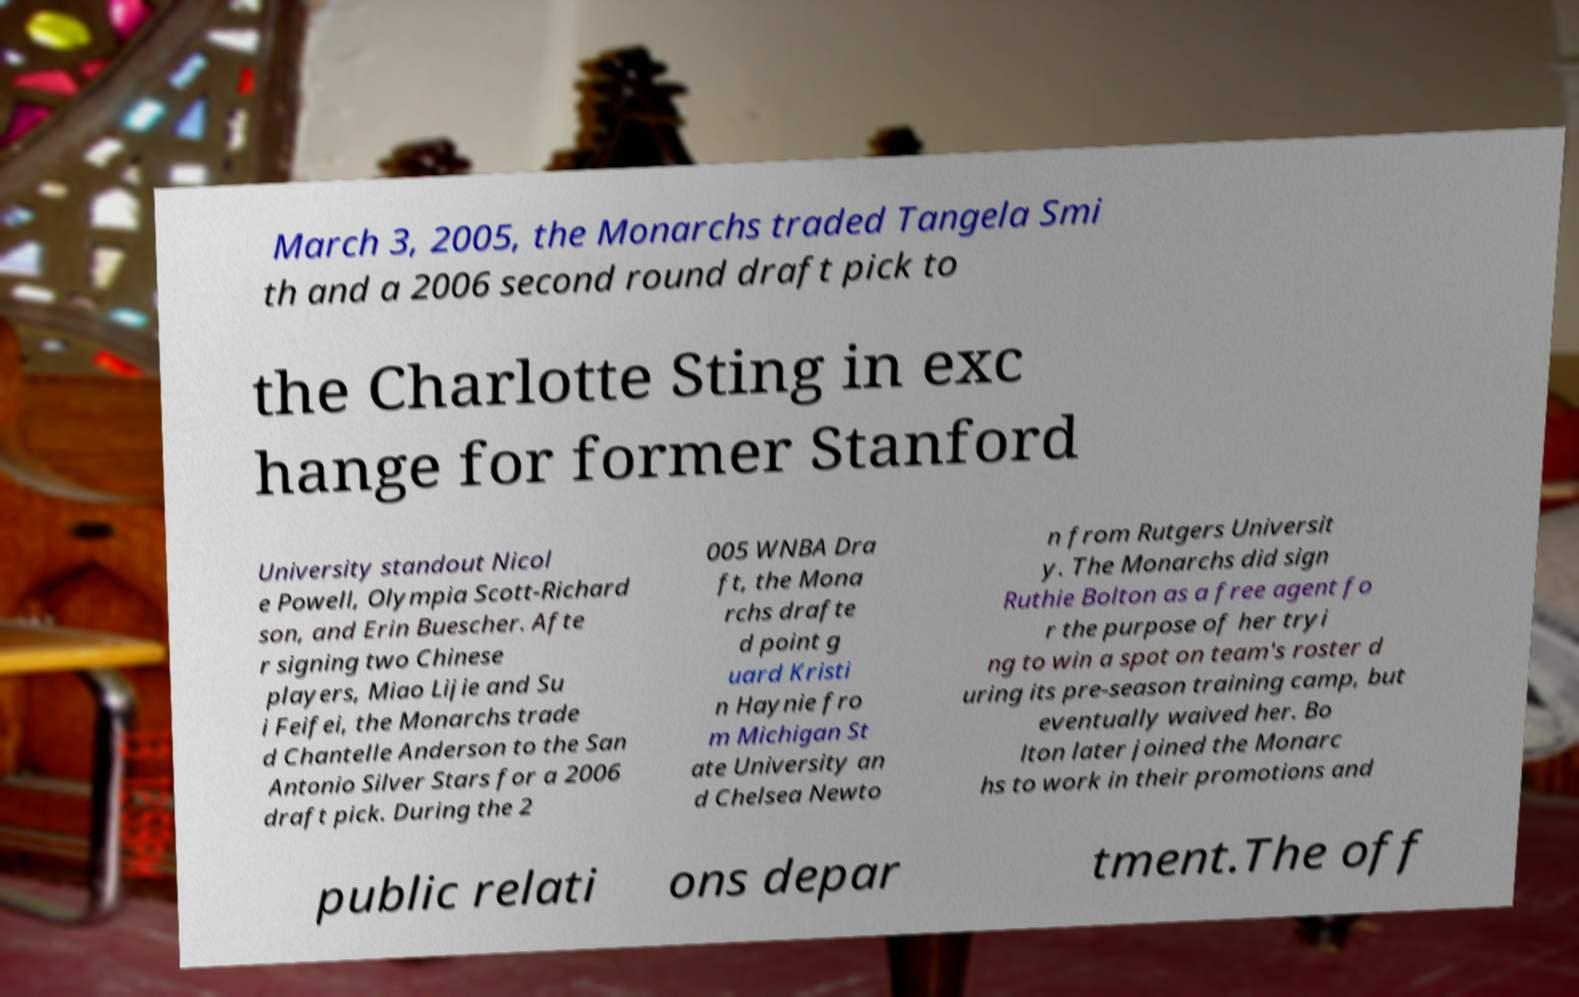There's text embedded in this image that I need extracted. Can you transcribe it verbatim? March 3, 2005, the Monarchs traded Tangela Smi th and a 2006 second round draft pick to the Charlotte Sting in exc hange for former Stanford University standout Nicol e Powell, Olympia Scott-Richard son, and Erin Buescher. Afte r signing two Chinese players, Miao Lijie and Su i Feifei, the Monarchs trade d Chantelle Anderson to the San Antonio Silver Stars for a 2006 draft pick. During the 2 005 WNBA Dra ft, the Mona rchs drafte d point g uard Kristi n Haynie fro m Michigan St ate University an d Chelsea Newto n from Rutgers Universit y. The Monarchs did sign Ruthie Bolton as a free agent fo r the purpose of her tryi ng to win a spot on team's roster d uring its pre-season training camp, but eventually waived her. Bo lton later joined the Monarc hs to work in their promotions and public relati ons depar tment.The off 